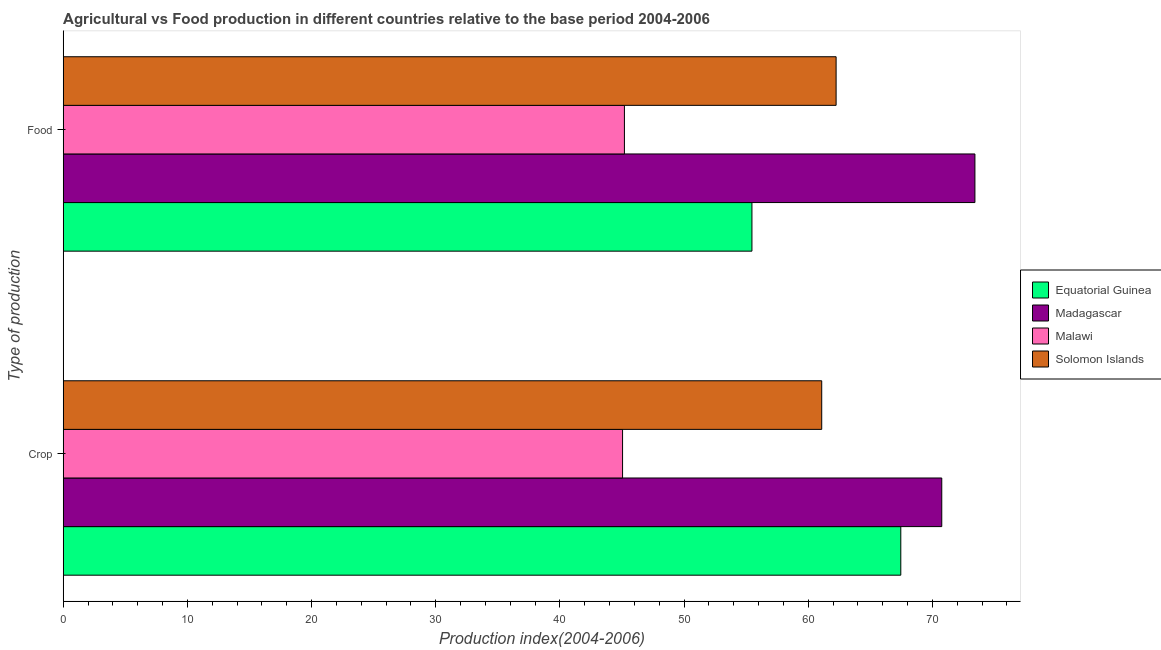How many groups of bars are there?
Ensure brevity in your answer.  2. Are the number of bars per tick equal to the number of legend labels?
Make the answer very short. Yes. What is the label of the 1st group of bars from the top?
Your answer should be compact. Food. What is the crop production index in Equatorial Guinea?
Provide a short and direct response. 67.46. Across all countries, what is the maximum crop production index?
Your response must be concise. 70.76. Across all countries, what is the minimum food production index?
Ensure brevity in your answer.  45.2. In which country was the crop production index maximum?
Provide a succinct answer. Madagascar. In which country was the food production index minimum?
Offer a very short reply. Malawi. What is the total food production index in the graph?
Make the answer very short. 236.35. What is the difference between the food production index in Solomon Islands and that in Malawi?
Your response must be concise. 17.05. What is the difference between the food production index in Equatorial Guinea and the crop production index in Madagascar?
Provide a succinct answer. -15.29. What is the average crop production index per country?
Offer a terse response. 61.09. What is the difference between the crop production index and food production index in Equatorial Guinea?
Provide a short and direct response. 11.99. In how many countries, is the food production index greater than 16 ?
Offer a very short reply. 4. What is the ratio of the crop production index in Madagascar to that in Solomon Islands?
Your answer should be very brief. 1.16. Is the food production index in Solomon Islands less than that in Madagascar?
Offer a very short reply. Yes. In how many countries, is the crop production index greater than the average crop production index taken over all countries?
Keep it short and to the point. 3. What does the 2nd bar from the top in Crop represents?
Give a very brief answer. Malawi. What does the 1st bar from the bottom in Crop represents?
Your response must be concise. Equatorial Guinea. Are all the bars in the graph horizontal?
Ensure brevity in your answer.  Yes. Does the graph contain grids?
Your response must be concise. No. How many legend labels are there?
Provide a succinct answer. 4. What is the title of the graph?
Provide a succinct answer. Agricultural vs Food production in different countries relative to the base period 2004-2006. What is the label or title of the X-axis?
Your answer should be very brief. Production index(2004-2006). What is the label or title of the Y-axis?
Provide a short and direct response. Type of production. What is the Production index(2004-2006) in Equatorial Guinea in Crop?
Your answer should be compact. 67.46. What is the Production index(2004-2006) of Madagascar in Crop?
Your answer should be very brief. 70.76. What is the Production index(2004-2006) in Malawi in Crop?
Keep it short and to the point. 45.05. What is the Production index(2004-2006) of Solomon Islands in Crop?
Your response must be concise. 61.09. What is the Production index(2004-2006) in Equatorial Guinea in Food?
Your response must be concise. 55.47. What is the Production index(2004-2006) of Madagascar in Food?
Give a very brief answer. 73.43. What is the Production index(2004-2006) of Malawi in Food?
Keep it short and to the point. 45.2. What is the Production index(2004-2006) in Solomon Islands in Food?
Ensure brevity in your answer.  62.25. Across all Type of production, what is the maximum Production index(2004-2006) in Equatorial Guinea?
Offer a very short reply. 67.46. Across all Type of production, what is the maximum Production index(2004-2006) in Madagascar?
Your answer should be compact. 73.43. Across all Type of production, what is the maximum Production index(2004-2006) of Malawi?
Your answer should be compact. 45.2. Across all Type of production, what is the maximum Production index(2004-2006) of Solomon Islands?
Provide a succinct answer. 62.25. Across all Type of production, what is the minimum Production index(2004-2006) in Equatorial Guinea?
Your answer should be compact. 55.47. Across all Type of production, what is the minimum Production index(2004-2006) of Madagascar?
Your response must be concise. 70.76. Across all Type of production, what is the minimum Production index(2004-2006) of Malawi?
Your answer should be compact. 45.05. Across all Type of production, what is the minimum Production index(2004-2006) in Solomon Islands?
Your answer should be compact. 61.09. What is the total Production index(2004-2006) of Equatorial Guinea in the graph?
Provide a short and direct response. 122.93. What is the total Production index(2004-2006) of Madagascar in the graph?
Ensure brevity in your answer.  144.19. What is the total Production index(2004-2006) in Malawi in the graph?
Your answer should be very brief. 90.25. What is the total Production index(2004-2006) in Solomon Islands in the graph?
Ensure brevity in your answer.  123.34. What is the difference between the Production index(2004-2006) in Equatorial Guinea in Crop and that in Food?
Keep it short and to the point. 11.99. What is the difference between the Production index(2004-2006) of Madagascar in Crop and that in Food?
Provide a succinct answer. -2.67. What is the difference between the Production index(2004-2006) of Solomon Islands in Crop and that in Food?
Provide a short and direct response. -1.16. What is the difference between the Production index(2004-2006) in Equatorial Guinea in Crop and the Production index(2004-2006) in Madagascar in Food?
Your response must be concise. -5.97. What is the difference between the Production index(2004-2006) in Equatorial Guinea in Crop and the Production index(2004-2006) in Malawi in Food?
Your answer should be compact. 22.26. What is the difference between the Production index(2004-2006) of Equatorial Guinea in Crop and the Production index(2004-2006) of Solomon Islands in Food?
Your answer should be very brief. 5.21. What is the difference between the Production index(2004-2006) in Madagascar in Crop and the Production index(2004-2006) in Malawi in Food?
Provide a succinct answer. 25.56. What is the difference between the Production index(2004-2006) of Madagascar in Crop and the Production index(2004-2006) of Solomon Islands in Food?
Make the answer very short. 8.51. What is the difference between the Production index(2004-2006) in Malawi in Crop and the Production index(2004-2006) in Solomon Islands in Food?
Your answer should be very brief. -17.2. What is the average Production index(2004-2006) of Equatorial Guinea per Type of production?
Ensure brevity in your answer.  61.47. What is the average Production index(2004-2006) in Madagascar per Type of production?
Your answer should be compact. 72.09. What is the average Production index(2004-2006) of Malawi per Type of production?
Your response must be concise. 45.12. What is the average Production index(2004-2006) in Solomon Islands per Type of production?
Make the answer very short. 61.67. What is the difference between the Production index(2004-2006) in Equatorial Guinea and Production index(2004-2006) in Madagascar in Crop?
Keep it short and to the point. -3.3. What is the difference between the Production index(2004-2006) of Equatorial Guinea and Production index(2004-2006) of Malawi in Crop?
Make the answer very short. 22.41. What is the difference between the Production index(2004-2006) in Equatorial Guinea and Production index(2004-2006) in Solomon Islands in Crop?
Provide a short and direct response. 6.37. What is the difference between the Production index(2004-2006) in Madagascar and Production index(2004-2006) in Malawi in Crop?
Offer a terse response. 25.71. What is the difference between the Production index(2004-2006) in Madagascar and Production index(2004-2006) in Solomon Islands in Crop?
Your answer should be compact. 9.67. What is the difference between the Production index(2004-2006) in Malawi and Production index(2004-2006) in Solomon Islands in Crop?
Give a very brief answer. -16.04. What is the difference between the Production index(2004-2006) in Equatorial Guinea and Production index(2004-2006) in Madagascar in Food?
Make the answer very short. -17.96. What is the difference between the Production index(2004-2006) of Equatorial Guinea and Production index(2004-2006) of Malawi in Food?
Give a very brief answer. 10.27. What is the difference between the Production index(2004-2006) in Equatorial Guinea and Production index(2004-2006) in Solomon Islands in Food?
Provide a succinct answer. -6.78. What is the difference between the Production index(2004-2006) of Madagascar and Production index(2004-2006) of Malawi in Food?
Offer a very short reply. 28.23. What is the difference between the Production index(2004-2006) of Madagascar and Production index(2004-2006) of Solomon Islands in Food?
Make the answer very short. 11.18. What is the difference between the Production index(2004-2006) of Malawi and Production index(2004-2006) of Solomon Islands in Food?
Offer a very short reply. -17.05. What is the ratio of the Production index(2004-2006) of Equatorial Guinea in Crop to that in Food?
Keep it short and to the point. 1.22. What is the ratio of the Production index(2004-2006) of Madagascar in Crop to that in Food?
Ensure brevity in your answer.  0.96. What is the ratio of the Production index(2004-2006) of Solomon Islands in Crop to that in Food?
Offer a terse response. 0.98. What is the difference between the highest and the second highest Production index(2004-2006) in Equatorial Guinea?
Provide a short and direct response. 11.99. What is the difference between the highest and the second highest Production index(2004-2006) of Madagascar?
Provide a succinct answer. 2.67. What is the difference between the highest and the second highest Production index(2004-2006) in Solomon Islands?
Give a very brief answer. 1.16. What is the difference between the highest and the lowest Production index(2004-2006) of Equatorial Guinea?
Your response must be concise. 11.99. What is the difference between the highest and the lowest Production index(2004-2006) of Madagascar?
Give a very brief answer. 2.67. What is the difference between the highest and the lowest Production index(2004-2006) in Malawi?
Provide a succinct answer. 0.15. What is the difference between the highest and the lowest Production index(2004-2006) in Solomon Islands?
Give a very brief answer. 1.16. 